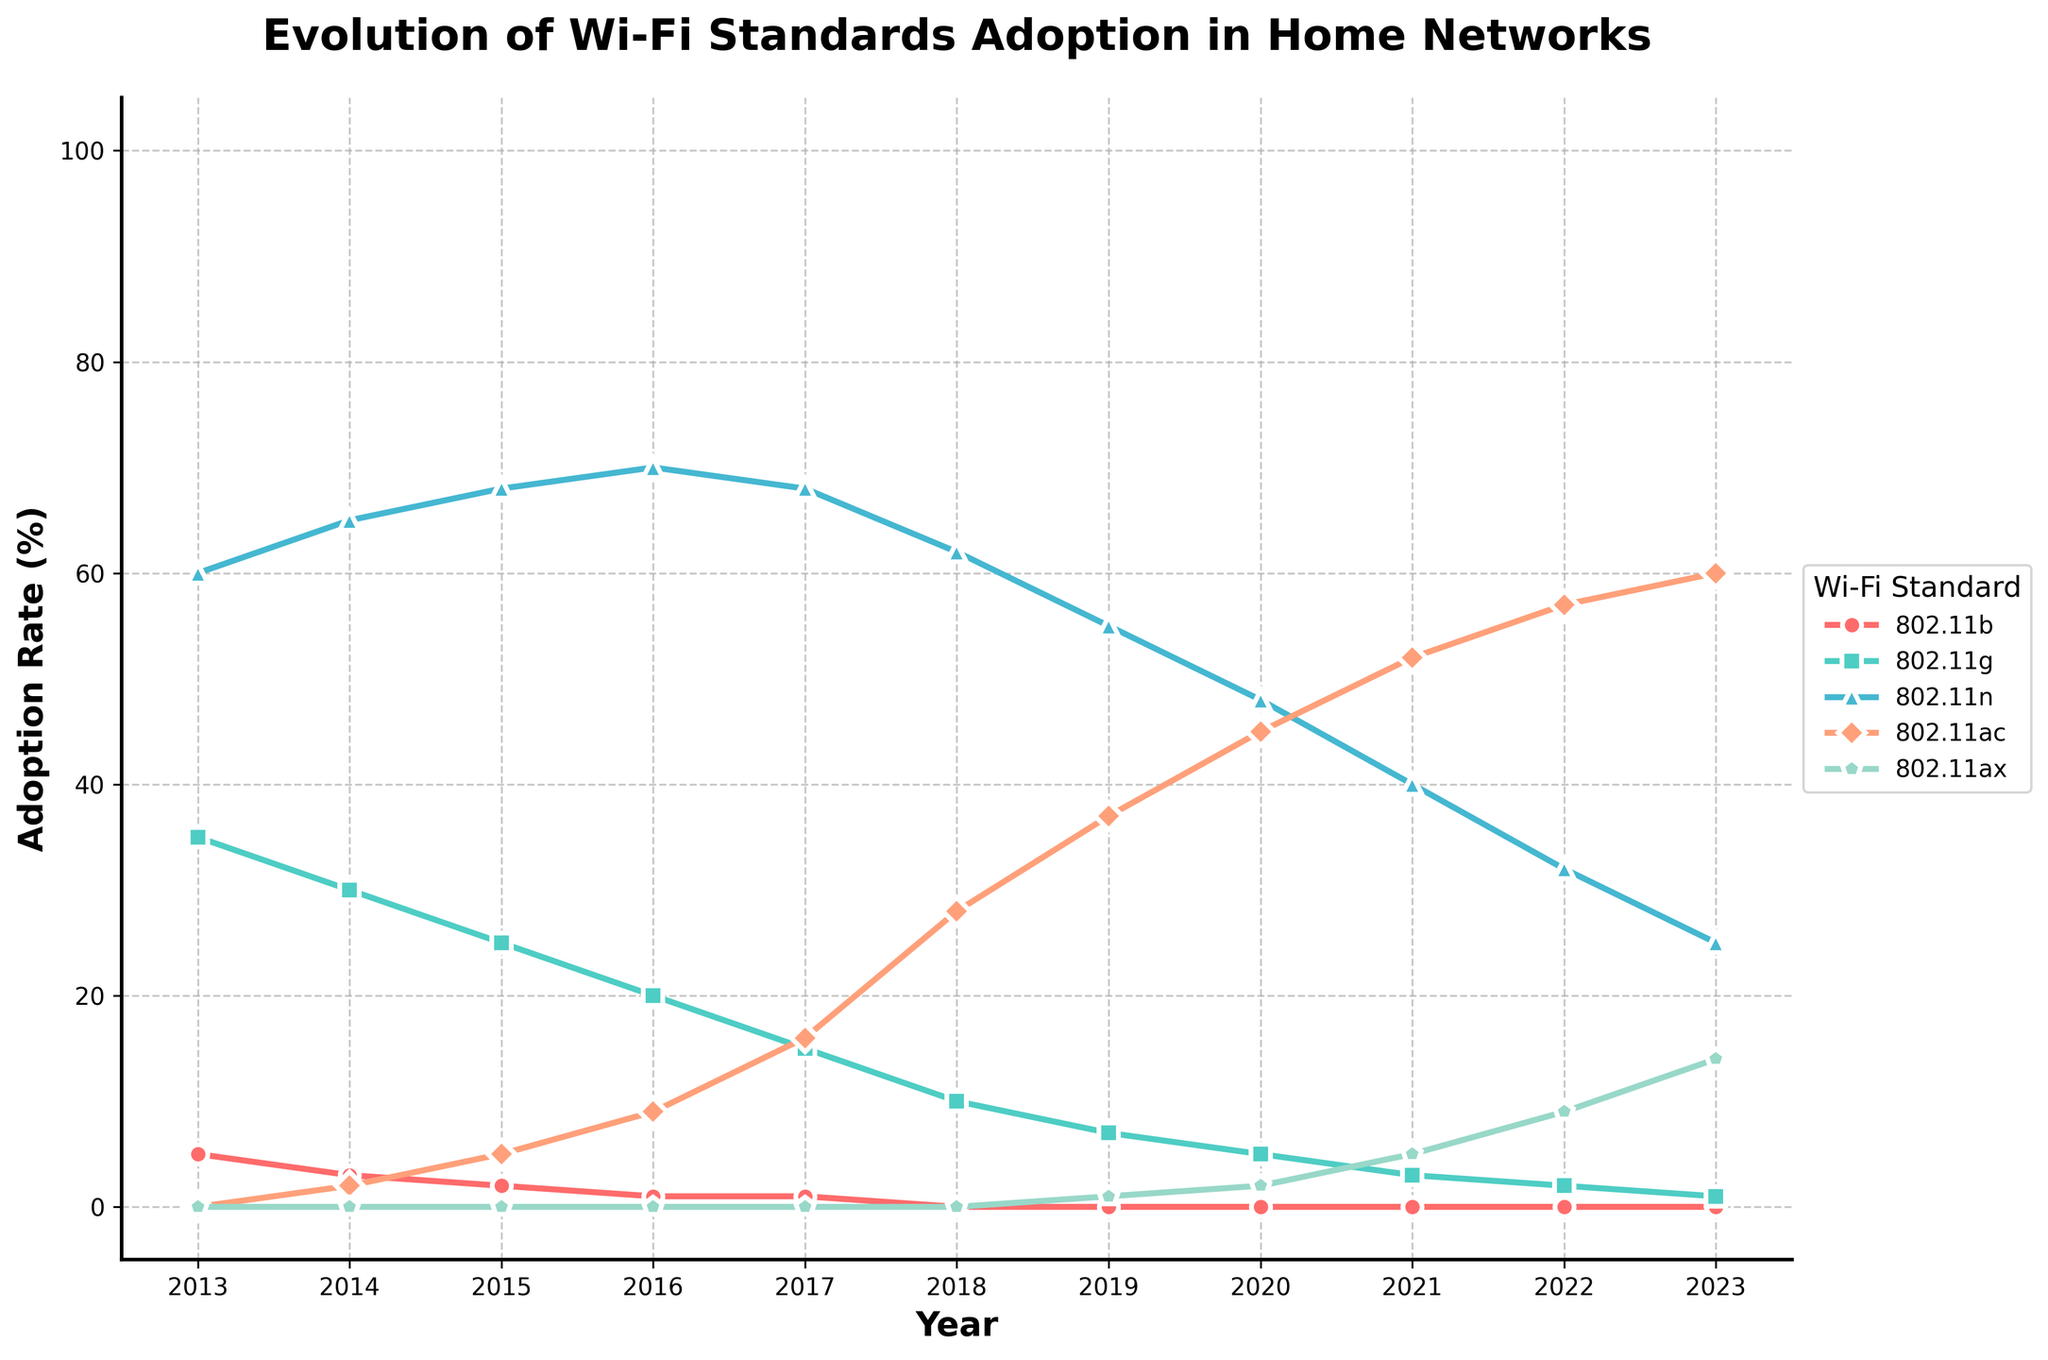How has the adoption rate of 802.11g changed from 2013 to 2023? In 2013, the adoption rate of 802.11g was 35%. By 2023, it decreased to 1%. The change is 35 - 1 = 34%.
Answer: Decreased by 34% Which Wi-Fi standard had the highest adoption rate in 2020? Looking at the 2020 data point, 802.11ac has the highest adoption rate with 45%.
Answer: 802.11ac Which year did 802.11ax start showing adoption, and what was the rate? 802.11ax first appears in the figure in 2019 with an adoption rate of 1%.
Answer: 2019, 1% In what years did 802.11n have an adoption rate higher than 50%? From 2013 to 2017 and 2019, the adoption rate of 802.11n was above 50%.
Answer: 2013 to 2017, 2019 Compare the adoption rate of 802.11n and 802.11ac in 2023. Which one is higher and by how much? In 2023, the adoption rate of 802.11n is 25% and 802.11ac is 60%. The difference is 60 - 25 = 35%.
Answer: 802.11ac by 35% What was the adoption rate of 802.11ax in 2022 and how much did it increase by 2023? In 2022, the adoption rate of 802.11ax was 9%. By 2023, it increased to 14%. The increase is 14 - 9 = 5%.
Answer: Increased by 5% Find the average adoption rate of 802.11b from 2013 to 2017. The adoption rates from 2013 to 2017 are 5, 3, 2, 1, and 1%. The average is (5 + 3 + 2 + 1 + 1) / 5 = 2.4%.
Answer: 2.4% Between which two consecutive years did 802.11ac see the largest increase in adoption rate? 802.11ac saw the largest increase between 2017 (16%) and 2018 (28%), which is 28 - 16 = 12%.
Answer: 2017 and 2018 What is the total decrease in the adoption rate of 802.11g from 2013 to 2023? The adoption rate in 2013 was 35% and in 2023 it is 1%. The total decrease is 35 - 1 = 34%.
Answer: 34% Which Wi-Fi standard had an adoption rate of 0% in 2018? In 2018, 802.11b had an adoption rate of 0%.
Answer: 802.11b 